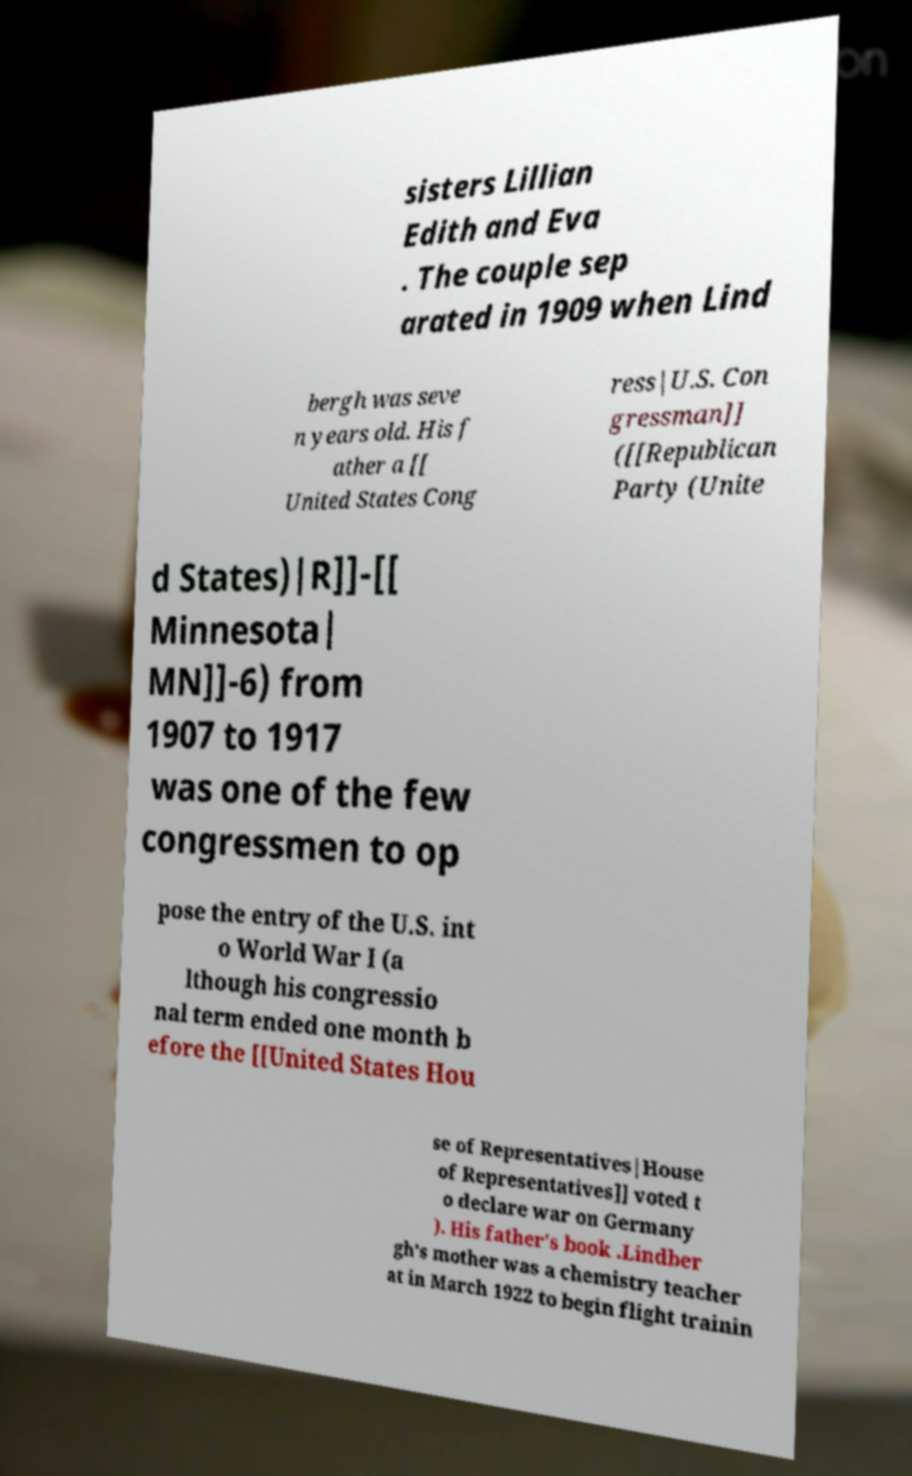Could you extract and type out the text from this image? sisters Lillian Edith and Eva . The couple sep arated in 1909 when Lind bergh was seve n years old. His f ather a [[ United States Cong ress|U.S. Con gressman]] ([[Republican Party (Unite d States)|R]]-[[ Minnesota| MN]]-6) from 1907 to 1917 was one of the few congressmen to op pose the entry of the U.S. int o World War I (a lthough his congressio nal term ended one month b efore the [[United States Hou se of Representatives|House of Representatives]] voted t o declare war on Germany ). His father's book .Lindber gh's mother was a chemistry teacher at in March 1922 to begin flight trainin 